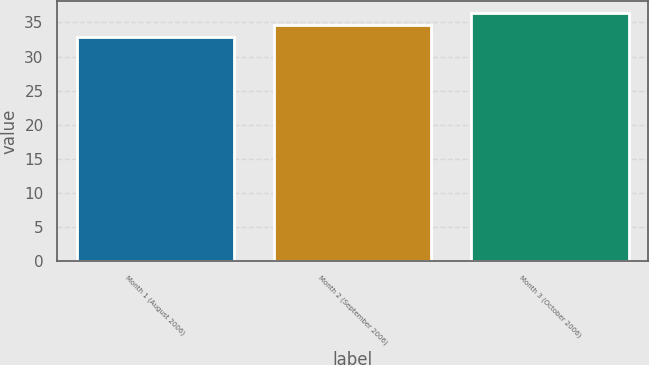Convert chart. <chart><loc_0><loc_0><loc_500><loc_500><bar_chart><fcel>Month 1 (August 2006)<fcel>Month 2 (September 2006)<fcel>Month 3 (October 2006)<nl><fcel>32.85<fcel>34.65<fcel>36.39<nl></chart> 